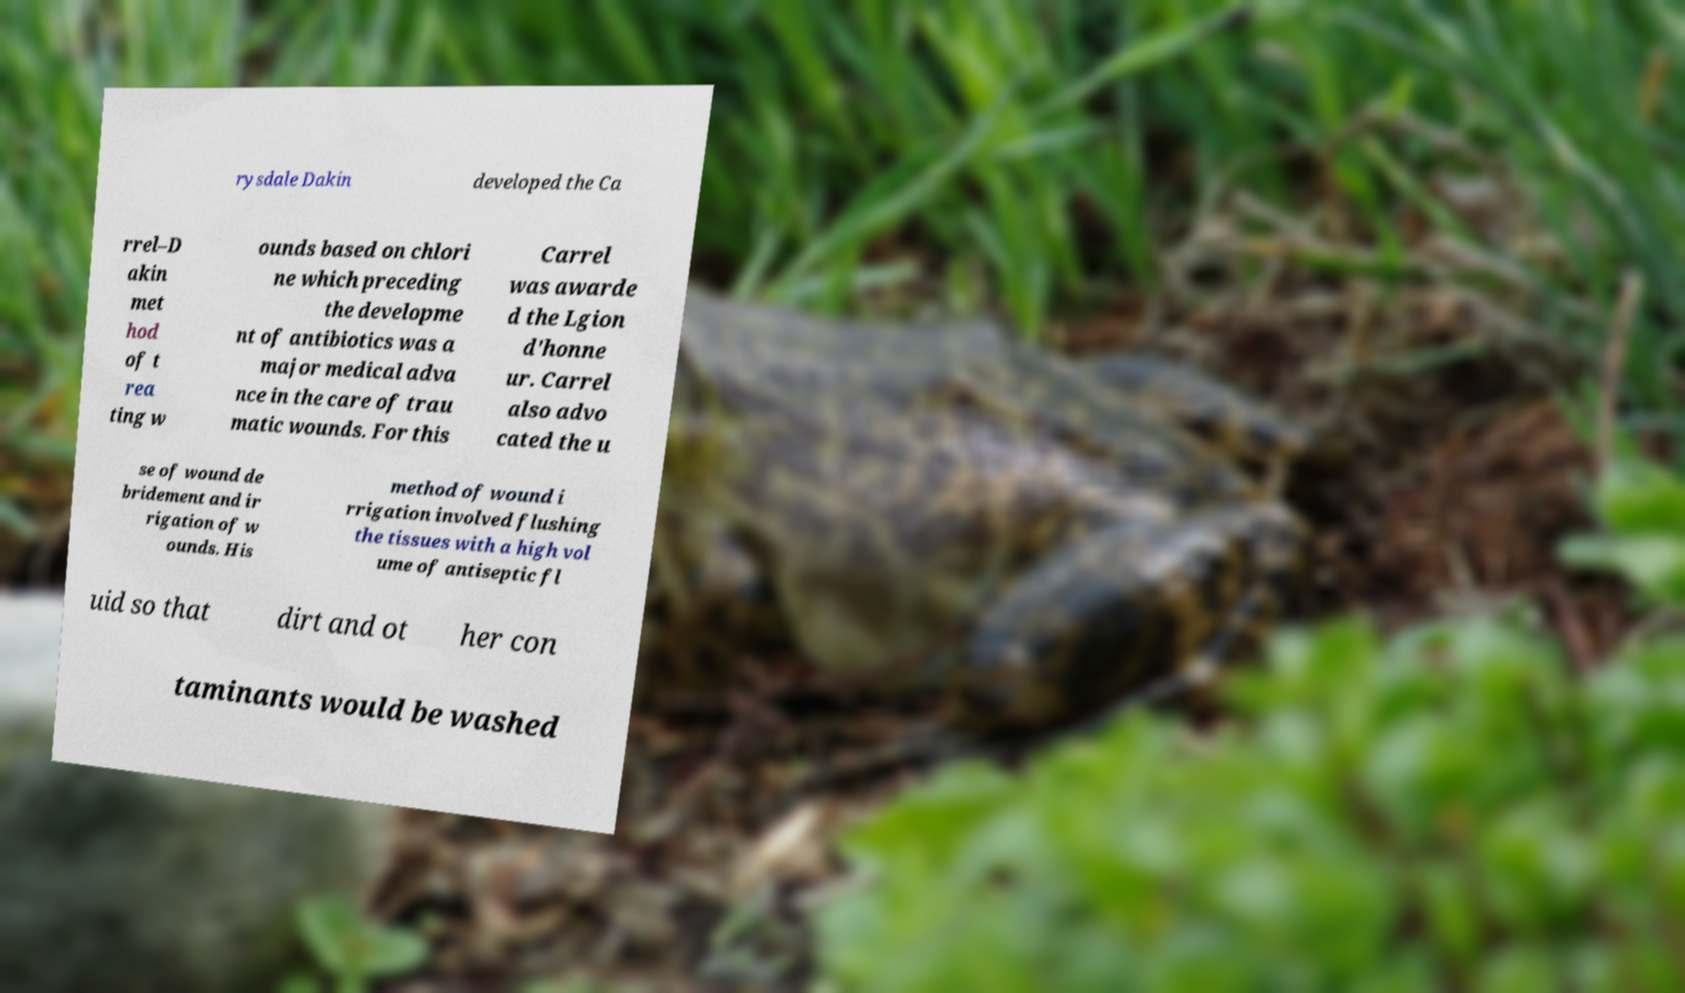Can you accurately transcribe the text from the provided image for me? rysdale Dakin developed the Ca rrel–D akin met hod of t rea ting w ounds based on chlori ne which preceding the developme nt of antibiotics was a major medical adva nce in the care of trau matic wounds. For this Carrel was awarde d the Lgion d'honne ur. Carrel also advo cated the u se of wound de bridement and ir rigation of w ounds. His method of wound i rrigation involved flushing the tissues with a high vol ume of antiseptic fl uid so that dirt and ot her con taminants would be washed 